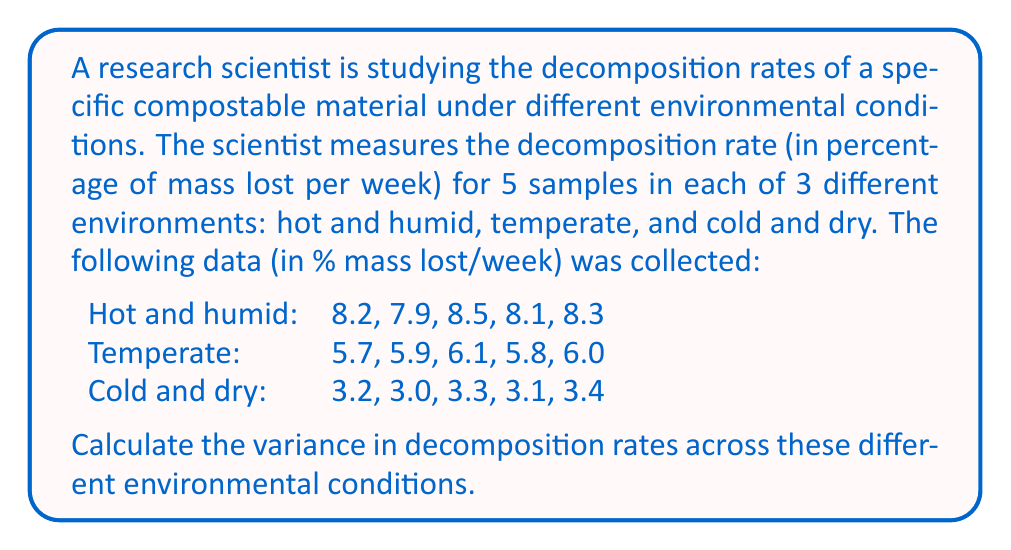Give your solution to this math problem. To calculate the variance in decomposition rates across different environmental conditions, we'll follow these steps:

1) First, calculate the mean decomposition rate for each environment:

   Hot and humid: $\mu_1 = \frac{8.2 + 7.9 + 8.5 + 8.1 + 8.3}{5} = 8.2$
   Temperate: $\mu_2 = \frac{5.7 + 5.9 + 6.1 + 5.8 + 6.0}{5} = 5.9$
   Cold and dry: $\mu_3 = \frac{3.2 + 3.0 + 3.3 + 3.1 + 3.4}{5} = 3.2$

2) Calculate the overall mean of these three environmental means:

   $\mu = \frac{\mu_1 + \mu_2 + \mu_3}{3} = \frac{8.2 + 5.9 + 3.2}{3} = 5.77$

3) Calculate the squared differences from the overall mean:

   $(8.2 - 5.77)^2 = 5.9049$
   $(5.9 - 5.77)^2 = 0.0169$
   $(3.2 - 5.77)^2 = 6.6049$

4) Sum these squared differences:

   $5.9049 + 0.0169 + 6.6049 = 12.5267$

5) Divide by the number of environments (3) to get the variance:

   Variance $= \frac{12.5267}{3} = 4.1756$

Therefore, the variance in decomposition rates across different environmental conditions is approximately 4.1756 (% mass lost/week)².
Answer: 4.1756 (% mass lost/week)² 